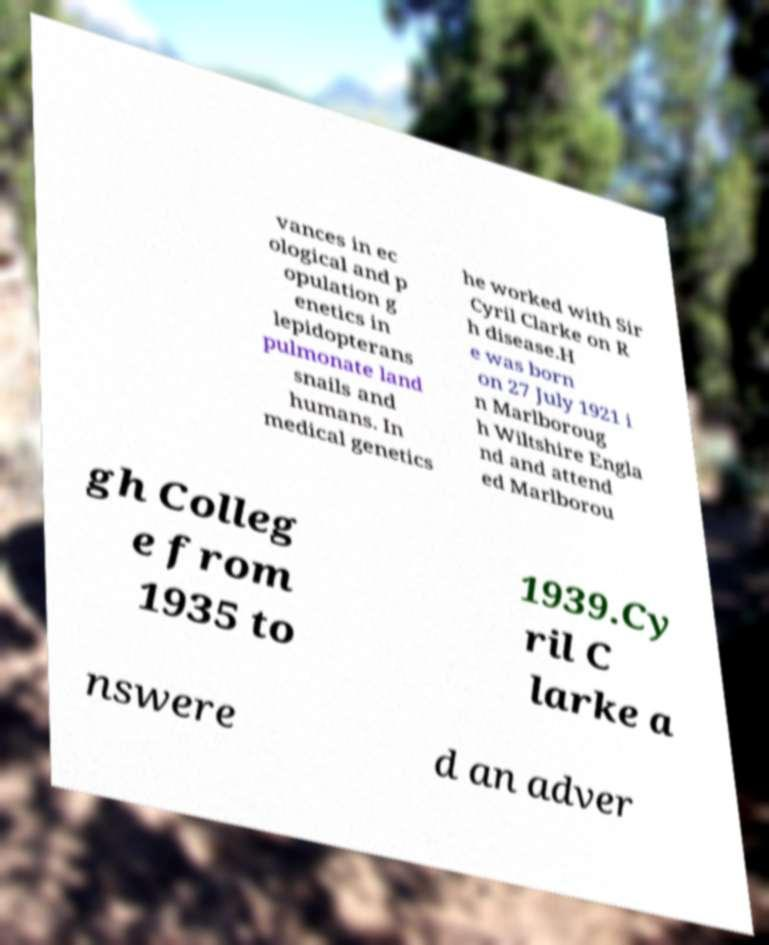What messages or text are displayed in this image? I need them in a readable, typed format. vances in ec ological and p opulation g enetics in lepidopterans pulmonate land snails and humans. In medical genetics he worked with Sir Cyril Clarke on R h disease.H e was born on 27 July 1921 i n Marlboroug h Wiltshire Engla nd and attend ed Marlborou gh Colleg e from 1935 to 1939.Cy ril C larke a nswere d an adver 